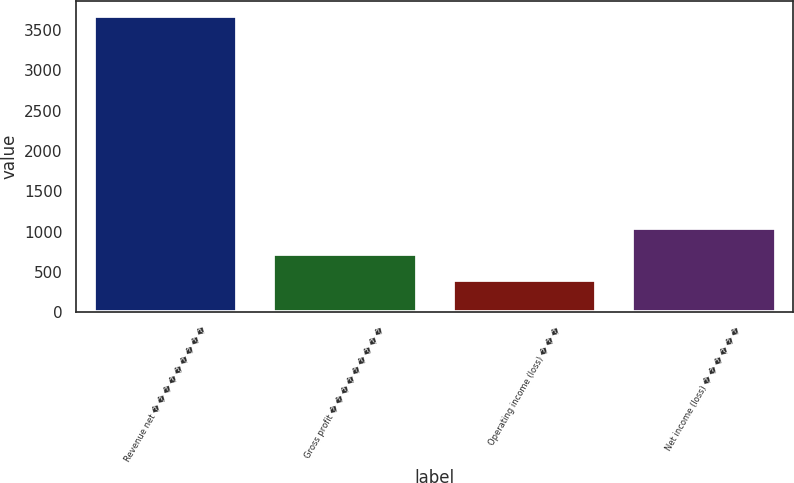<chart> <loc_0><loc_0><loc_500><loc_500><bar_chart><fcel>Revenue net � � � � � � � � �<fcel>Gross profit � � � � � � � � �<fcel>Operating income (loss) � � �<fcel>Net income (loss) � � � � � �<nl><fcel>3674<fcel>722<fcel>394<fcel>1050<nl></chart> 